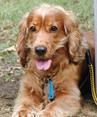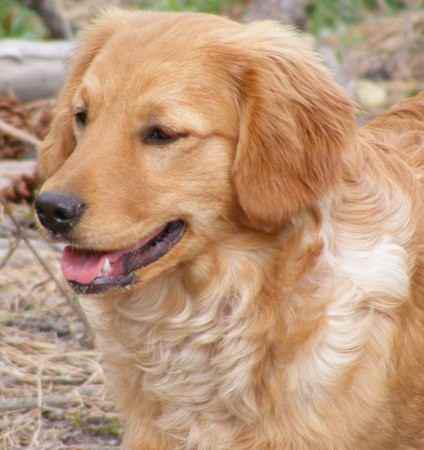The first image is the image on the left, the second image is the image on the right. Analyze the images presented: Is the assertion "A blue object hangs from the collar of the dog in one of the images." valid? Answer yes or no. Yes. 